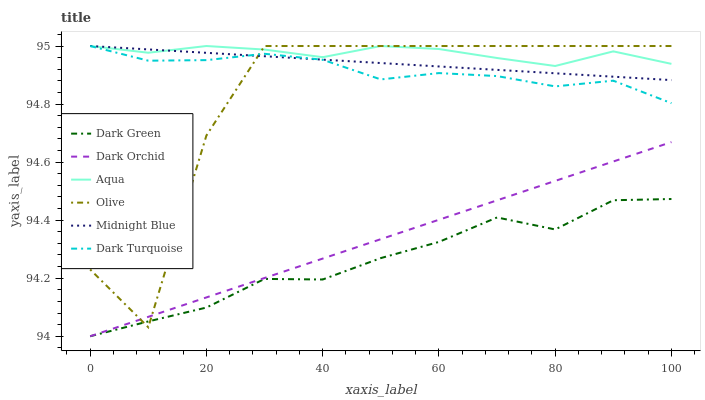Does Dark Green have the minimum area under the curve?
Answer yes or no. Yes. Does Aqua have the maximum area under the curve?
Answer yes or no. Yes. Does Dark Turquoise have the minimum area under the curve?
Answer yes or no. No. Does Dark Turquoise have the maximum area under the curve?
Answer yes or no. No. Is Midnight Blue the smoothest?
Answer yes or no. Yes. Is Olive the roughest?
Answer yes or no. Yes. Is Dark Turquoise the smoothest?
Answer yes or no. No. Is Dark Turquoise the roughest?
Answer yes or no. No. Does Dark Orchid have the lowest value?
Answer yes or no. Yes. Does Dark Turquoise have the lowest value?
Answer yes or no. No. Does Olive have the highest value?
Answer yes or no. Yes. Does Dark Orchid have the highest value?
Answer yes or no. No. Is Dark Green less than Midnight Blue?
Answer yes or no. Yes. Is Dark Turquoise greater than Dark Green?
Answer yes or no. Yes. Does Aqua intersect Dark Turquoise?
Answer yes or no. Yes. Is Aqua less than Dark Turquoise?
Answer yes or no. No. Is Aqua greater than Dark Turquoise?
Answer yes or no. No. Does Dark Green intersect Midnight Blue?
Answer yes or no. No. 